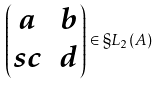<formula> <loc_0><loc_0><loc_500><loc_500>\begin{pmatrix} a & b \\ s c & d \end{pmatrix} \in \S L _ { 2 } ( A )</formula> 